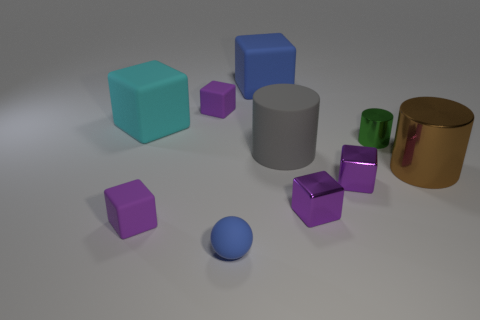Subtract all purple cubes. How many were subtracted if there are1purple cubes left? 3 Subtract all yellow cylinders. How many purple blocks are left? 4 Subtract all blue matte cubes. How many cubes are left? 5 Subtract all blue cubes. How many cubes are left? 5 Subtract all yellow cubes. Subtract all gray cylinders. How many cubes are left? 6 Subtract all spheres. How many objects are left? 9 Subtract 0 red cylinders. How many objects are left? 10 Subtract all large green shiny spheres. Subtract all small metal things. How many objects are left? 7 Add 3 large brown shiny cylinders. How many large brown shiny cylinders are left? 4 Add 1 green shiny objects. How many green shiny objects exist? 2 